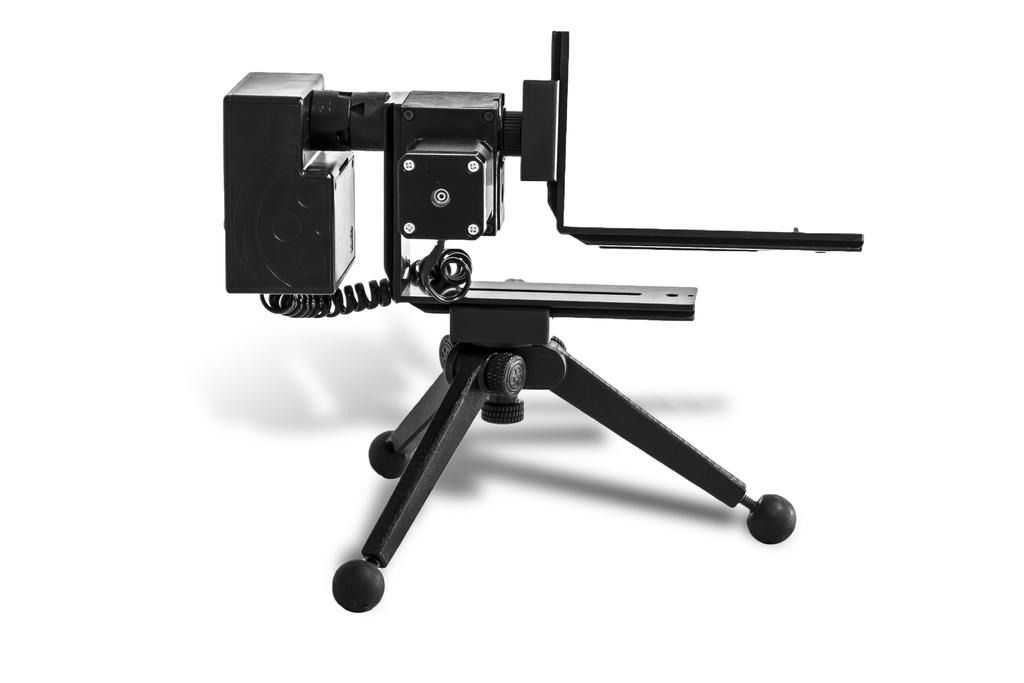What is the main object in the image? There is an object that looks like a camera in the image. Does the camera have any specific features? Yes, the camera has a stand. What is the color of the background in the image? The background of the image is white. What type of advertisement is visible on the camera in the image? There is no advertisement visible on the camera in the image. Can you tell me how many forks are placed on the camera in the image? There are no forks present in the image, let alone on the camera. What type of pipe can be seen connected to the camera in the image? There is no pipe connected to the camera in the image. 